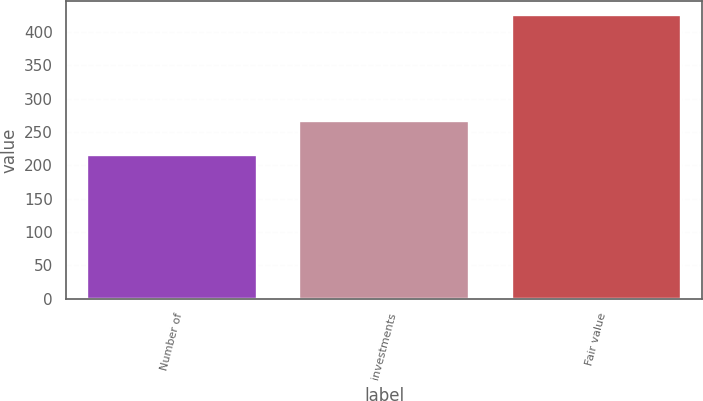Convert chart. <chart><loc_0><loc_0><loc_500><loc_500><bar_chart><fcel>Number of<fcel>investments<fcel>Fair value<nl><fcel>216<fcel>266<fcel>425<nl></chart> 